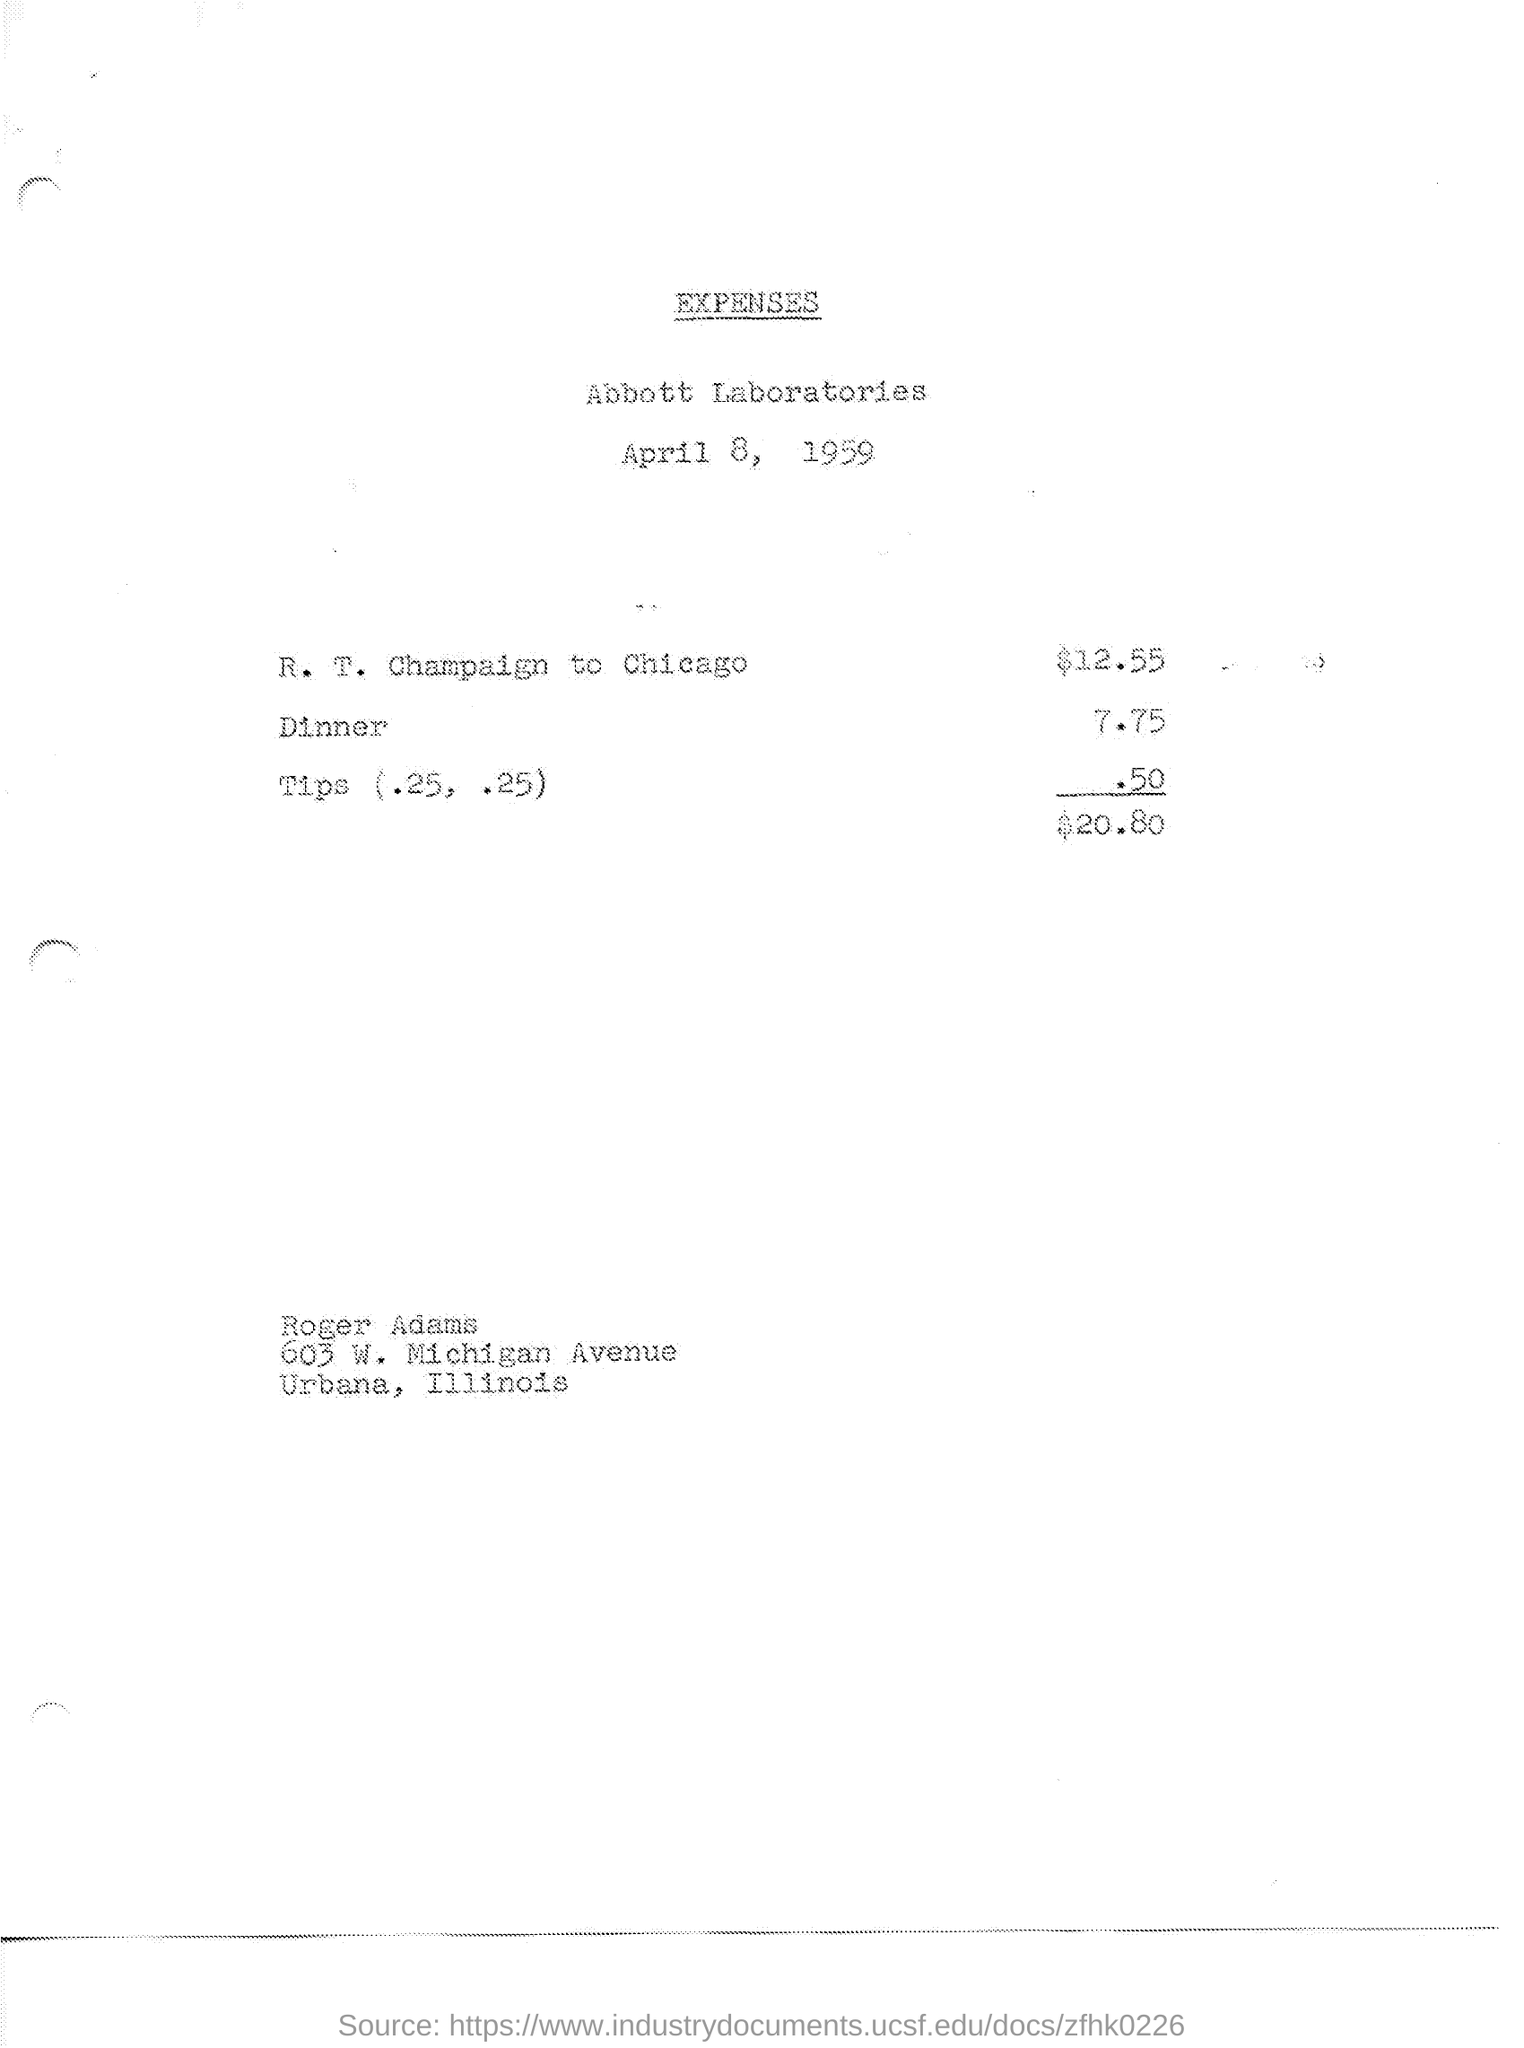Highlight a few significant elements in this photo. The document was created on April 8, 1959. I recently paid 7.75 for dinner, and the cost was quite reasonable. The cost of traveling from R.T Champaign to Chicago is $12.55. The amount is 50 cents. 